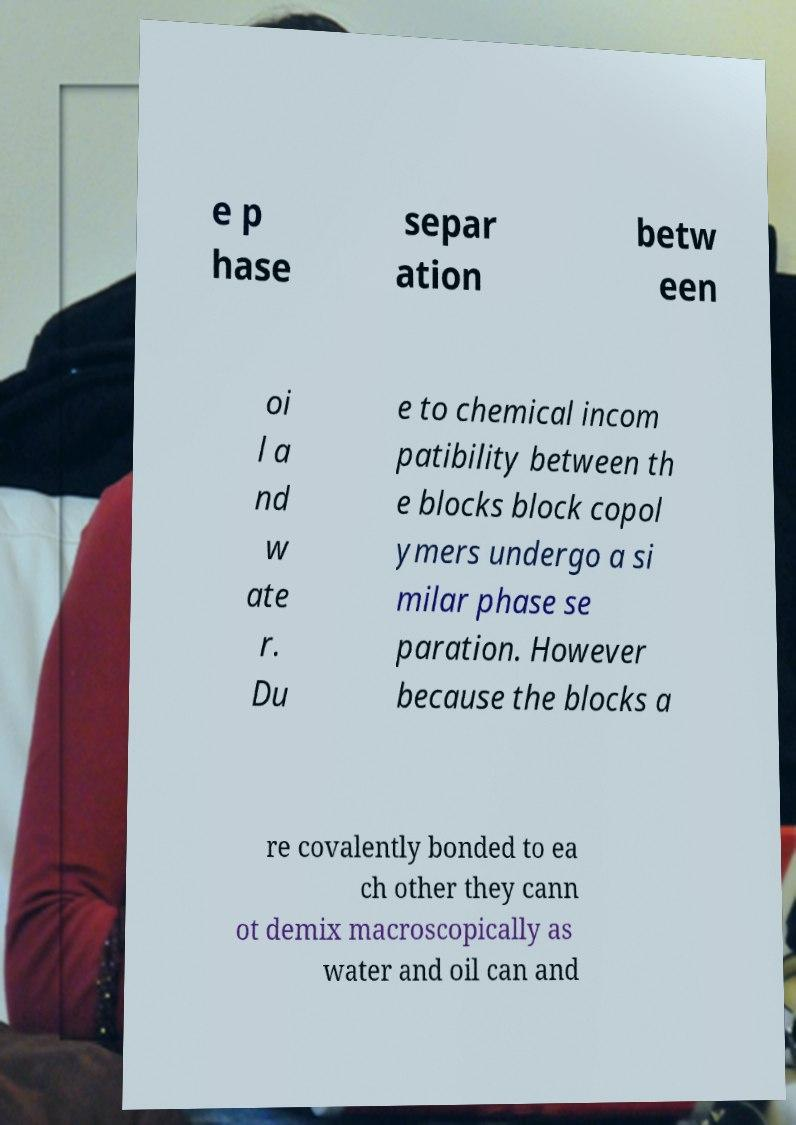Can you accurately transcribe the text from the provided image for me? e p hase separ ation betw een oi l a nd w ate r. Du e to chemical incom patibility between th e blocks block copol ymers undergo a si milar phase se paration. However because the blocks a re covalently bonded to ea ch other they cann ot demix macroscopically as water and oil can and 